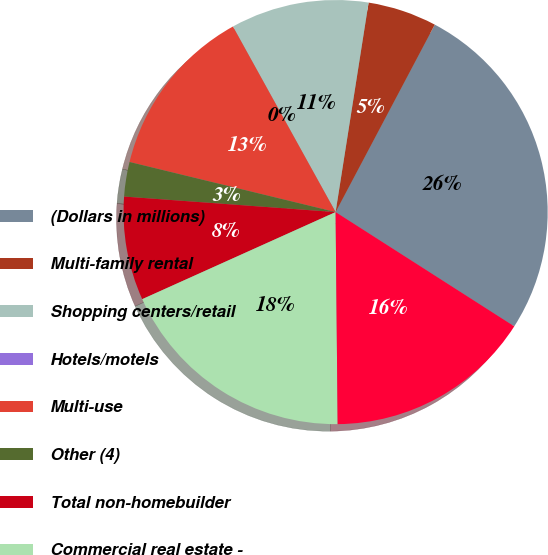Convert chart. <chart><loc_0><loc_0><loc_500><loc_500><pie_chart><fcel>(Dollars in millions)<fcel>Multi-family rental<fcel>Shopping centers/retail<fcel>Hotels/motels<fcel>Multi-use<fcel>Other (4)<fcel>Total non-homebuilder<fcel>Commercial real estate -<fcel>Total commercial real estate<nl><fcel>26.31%<fcel>5.26%<fcel>10.53%<fcel>0.0%<fcel>13.16%<fcel>2.63%<fcel>7.9%<fcel>18.42%<fcel>15.79%<nl></chart> 